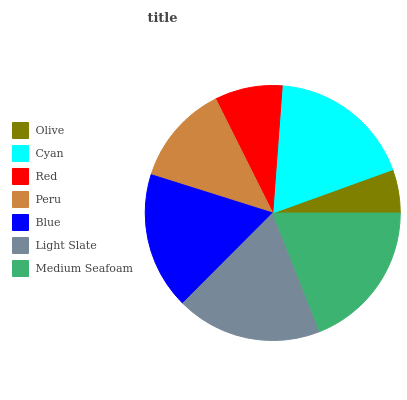Is Olive the minimum?
Answer yes or no. Yes. Is Medium Seafoam the maximum?
Answer yes or no. Yes. Is Cyan the minimum?
Answer yes or no. No. Is Cyan the maximum?
Answer yes or no. No. Is Cyan greater than Olive?
Answer yes or no. Yes. Is Olive less than Cyan?
Answer yes or no. Yes. Is Olive greater than Cyan?
Answer yes or no. No. Is Cyan less than Olive?
Answer yes or no. No. Is Blue the high median?
Answer yes or no. Yes. Is Blue the low median?
Answer yes or no. Yes. Is Medium Seafoam the high median?
Answer yes or no. No. Is Olive the low median?
Answer yes or no. No. 